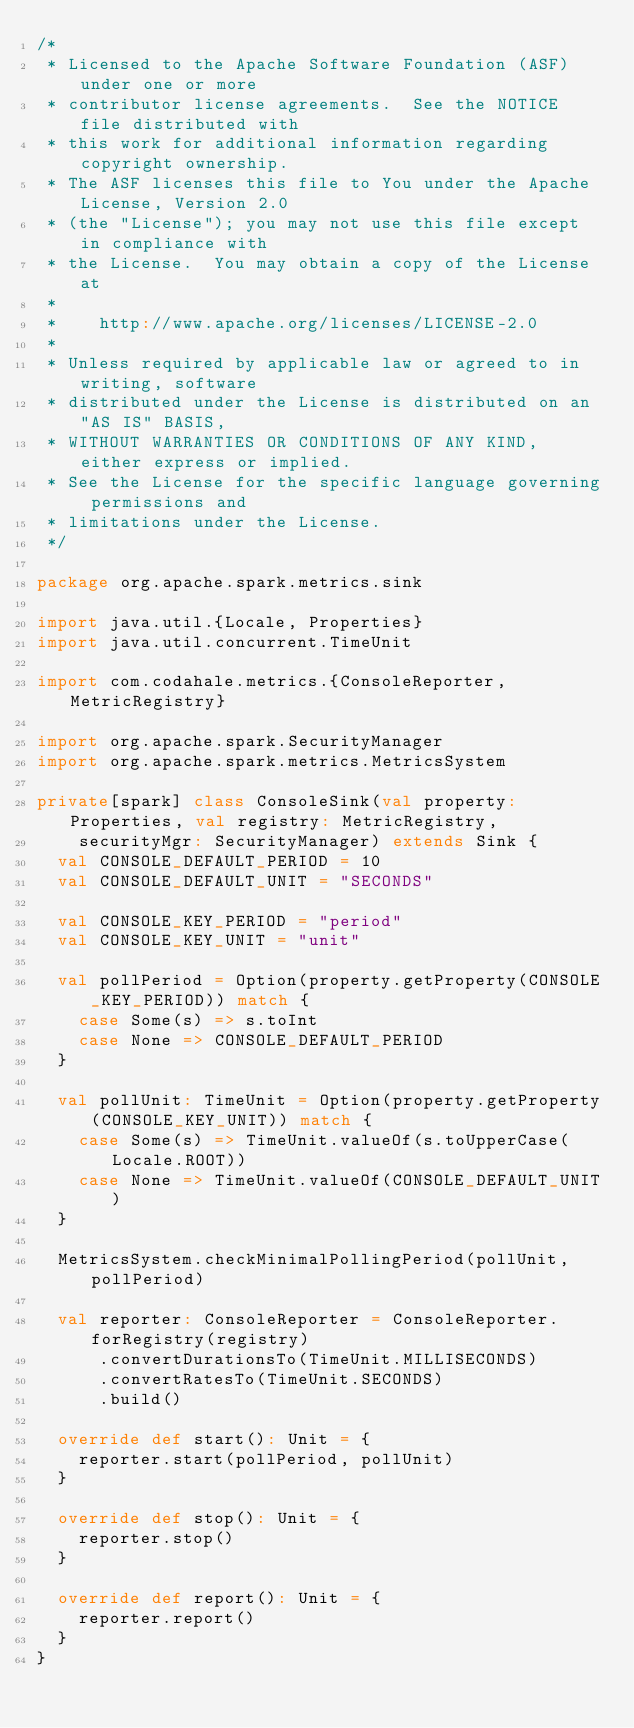<code> <loc_0><loc_0><loc_500><loc_500><_Scala_>/*
 * Licensed to the Apache Software Foundation (ASF) under one or more
 * contributor license agreements.  See the NOTICE file distributed with
 * this work for additional information regarding copyright ownership.
 * The ASF licenses this file to You under the Apache License, Version 2.0
 * (the "License"); you may not use this file except in compliance with
 * the License.  You may obtain a copy of the License at
 *
 *    http://www.apache.org/licenses/LICENSE-2.0
 *
 * Unless required by applicable law or agreed to in writing, software
 * distributed under the License is distributed on an "AS IS" BASIS,
 * WITHOUT WARRANTIES OR CONDITIONS OF ANY KIND, either express or implied.
 * See the License for the specific language governing permissions and
 * limitations under the License.
 */

package org.apache.spark.metrics.sink

import java.util.{Locale, Properties}
import java.util.concurrent.TimeUnit

import com.codahale.metrics.{ConsoleReporter, MetricRegistry}

import org.apache.spark.SecurityManager
import org.apache.spark.metrics.MetricsSystem

private[spark] class ConsoleSink(val property: Properties, val registry: MetricRegistry,
    securityMgr: SecurityManager) extends Sink {
  val CONSOLE_DEFAULT_PERIOD = 10
  val CONSOLE_DEFAULT_UNIT = "SECONDS"

  val CONSOLE_KEY_PERIOD = "period"
  val CONSOLE_KEY_UNIT = "unit"

  val pollPeriod = Option(property.getProperty(CONSOLE_KEY_PERIOD)) match {
    case Some(s) => s.toInt
    case None => CONSOLE_DEFAULT_PERIOD
  }

  val pollUnit: TimeUnit = Option(property.getProperty(CONSOLE_KEY_UNIT)) match {
    case Some(s) => TimeUnit.valueOf(s.toUpperCase(Locale.ROOT))
    case None => TimeUnit.valueOf(CONSOLE_DEFAULT_UNIT)
  }

  MetricsSystem.checkMinimalPollingPeriod(pollUnit, pollPeriod)

  val reporter: ConsoleReporter = ConsoleReporter.forRegistry(registry)
      .convertDurationsTo(TimeUnit.MILLISECONDS)
      .convertRatesTo(TimeUnit.SECONDS)
      .build()

  override def start(): Unit = {
    reporter.start(pollPeriod, pollUnit)
  }

  override def stop(): Unit = {
    reporter.stop()
  }

  override def report(): Unit = {
    reporter.report()
  }
}

</code> 